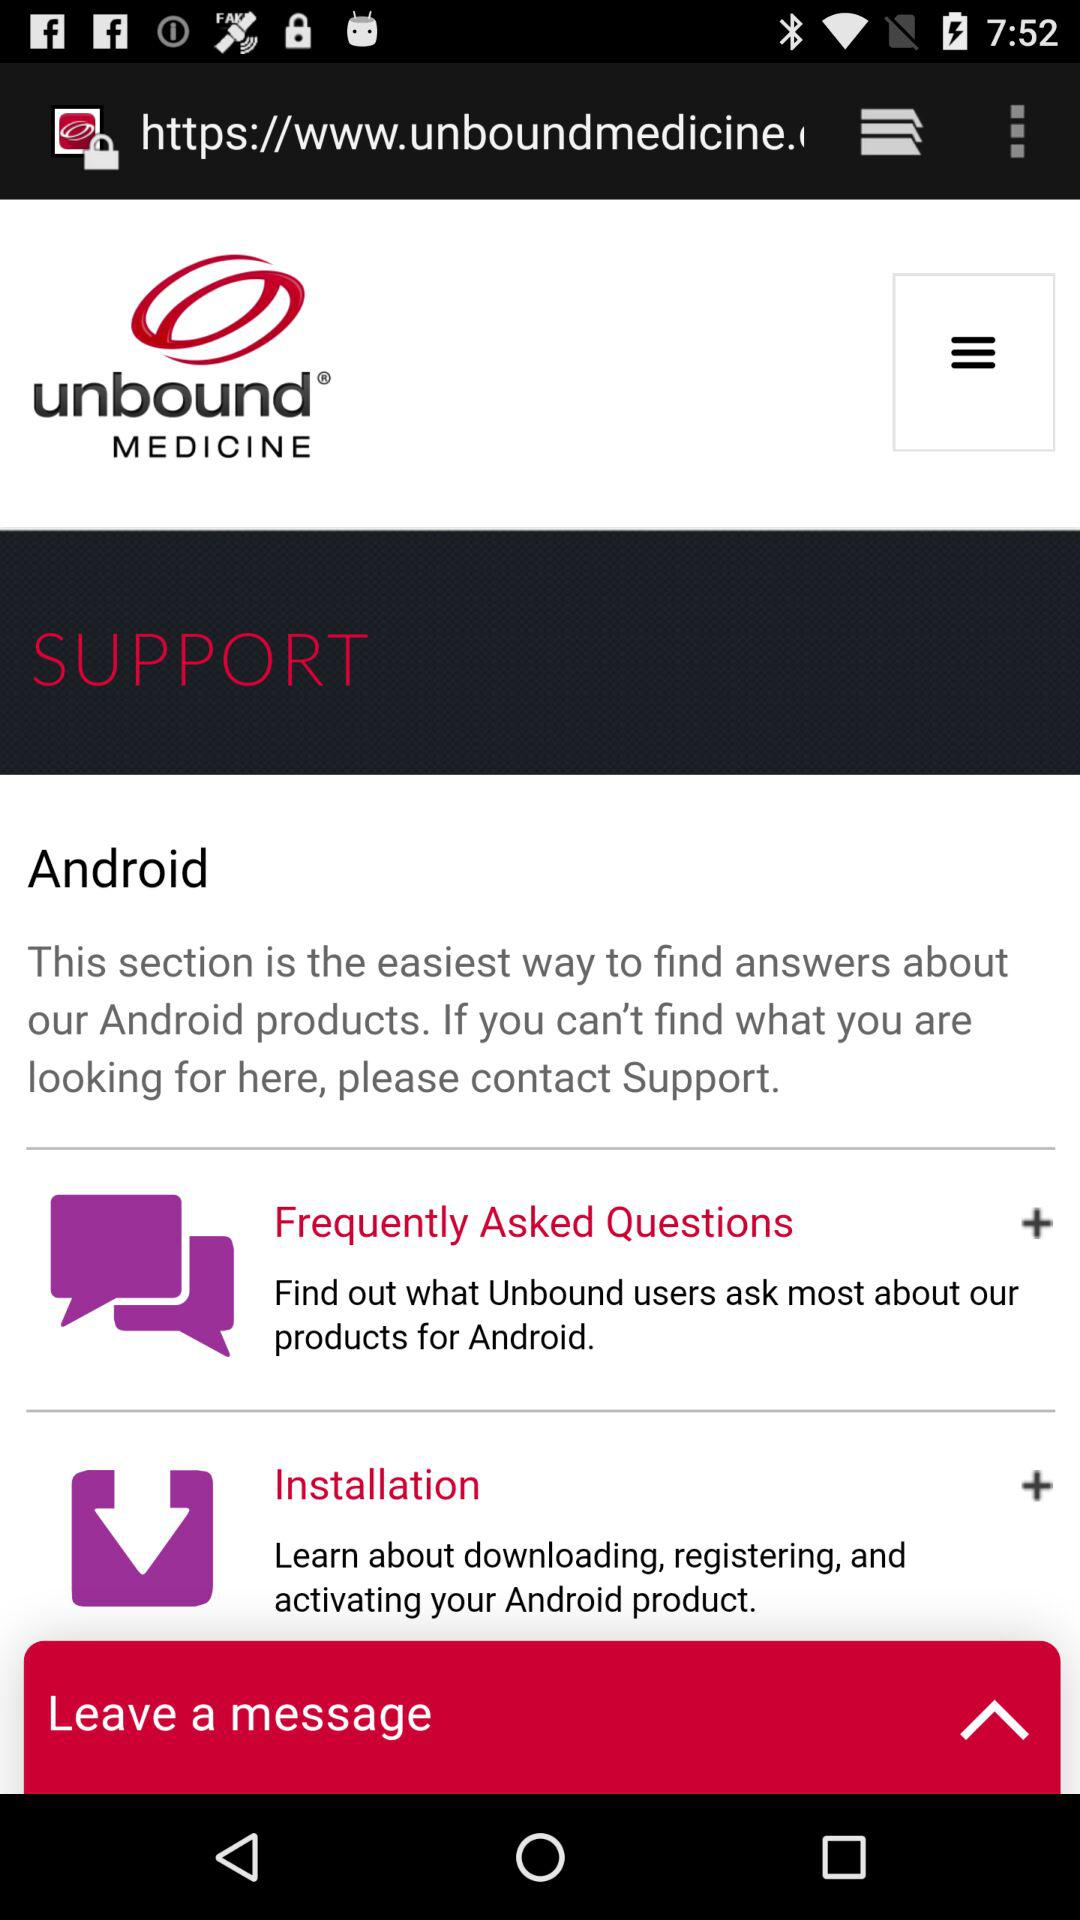What is the app name? The app name is "unbound MEDICINE". 